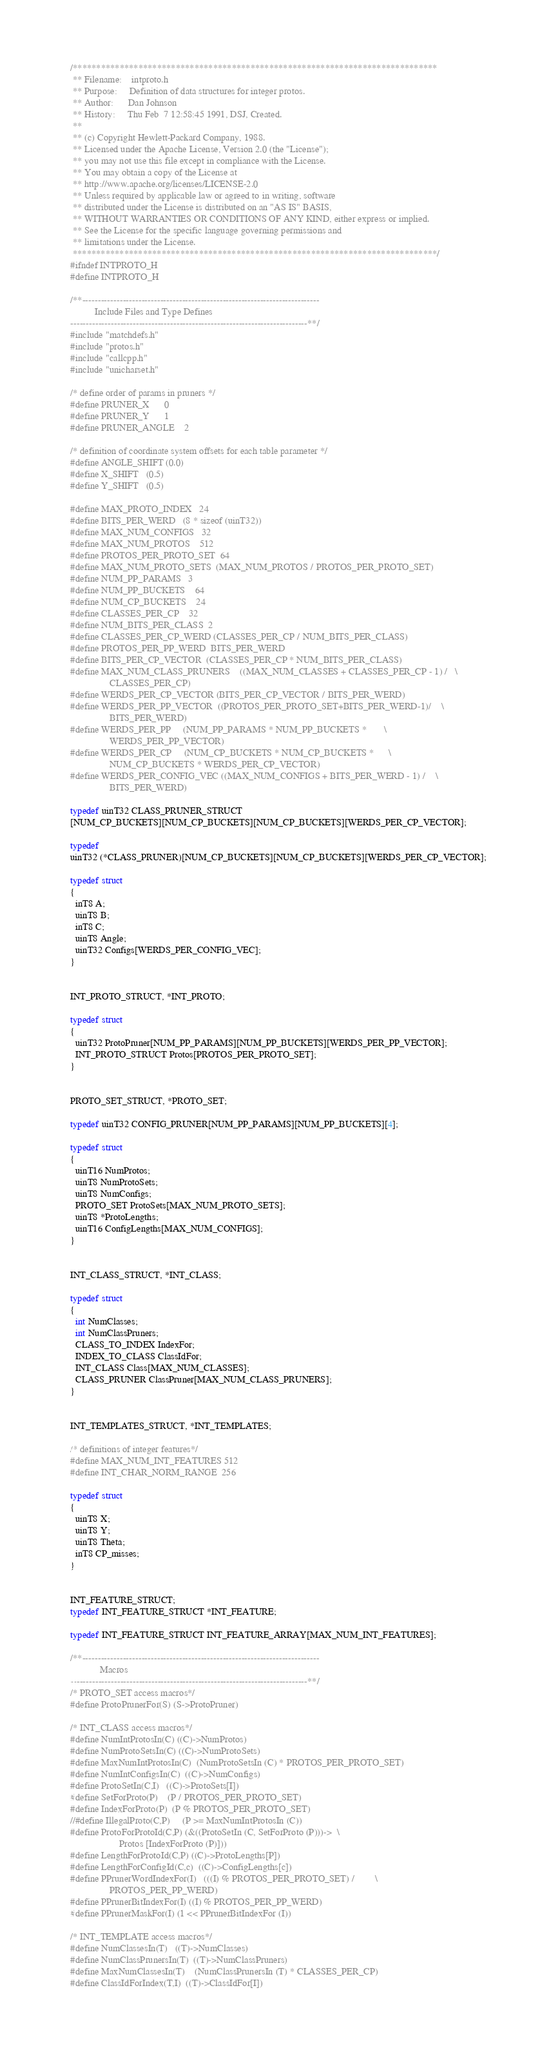Convert code to text. <code><loc_0><loc_0><loc_500><loc_500><_C_>/******************************************************************************
 **	Filename:    intproto.h
 **	Purpose:     Definition of data structures for integer protos.
 **	Author:      Dan Johnson
 **	History:     Thu Feb  7 12:58:45 1991, DSJ, Created.
 **
 **	(c) Copyright Hewlett-Packard Company, 1988.
 ** Licensed under the Apache License, Version 2.0 (the "License");
 ** you may not use this file except in compliance with the License.
 ** You may obtain a copy of the License at
 ** http://www.apache.org/licenses/LICENSE-2.0
 ** Unless required by applicable law or agreed to in writing, software
 ** distributed under the License is distributed on an "AS IS" BASIS,
 ** WITHOUT WARRANTIES OR CONDITIONS OF ANY KIND, either express or implied.
 ** See the License for the specific language governing permissions and
 ** limitations under the License.
 ******************************************************************************/
#ifndef INTPROTO_H
#define INTPROTO_H

/**----------------------------------------------------------------------------
          Include Files and Type Defines
----------------------------------------------------------------------------**/
#include "matchdefs.h"
#include "protos.h"
#include "callcpp.h"
#include "unicharset.h"

/* define order of params in pruners */
#define PRUNER_X      0
#define PRUNER_Y      1
#define PRUNER_ANGLE    2

/* definition of coordinate system offsets for each table parameter */
#define ANGLE_SHIFT (0.0)
#define X_SHIFT   (0.5)
#define Y_SHIFT   (0.5)

#define MAX_PROTO_INDEX   24
#define BITS_PER_WERD   (8 * sizeof (uinT32))
#define MAX_NUM_CONFIGS   32
#define MAX_NUM_PROTOS    512
#define PROTOS_PER_PROTO_SET  64
#define MAX_NUM_PROTO_SETS  (MAX_NUM_PROTOS / PROTOS_PER_PROTO_SET)
#define NUM_PP_PARAMS   3
#define NUM_PP_BUCKETS    64
#define NUM_CP_BUCKETS    24
#define CLASSES_PER_CP    32
#define NUM_BITS_PER_CLASS  2
#define CLASSES_PER_CP_WERD (CLASSES_PER_CP / NUM_BITS_PER_CLASS)
#define PROTOS_PER_PP_WERD  BITS_PER_WERD
#define BITS_PER_CP_VECTOR  (CLASSES_PER_CP * NUM_BITS_PER_CLASS)
#define MAX_NUM_CLASS_PRUNERS	((MAX_NUM_CLASSES + CLASSES_PER_CP - 1) /   \
				CLASSES_PER_CP)
#define WERDS_PER_CP_VECTOR (BITS_PER_CP_VECTOR / BITS_PER_WERD)
#define WERDS_PER_PP_VECTOR	((PROTOS_PER_PROTO_SET+BITS_PER_WERD-1)/    \
				BITS_PER_WERD)
#define WERDS_PER_PP		(NUM_PP_PARAMS * NUM_PP_BUCKETS *		\
				WERDS_PER_PP_VECTOR)
#define WERDS_PER_CP		(NUM_CP_BUCKETS * NUM_CP_BUCKETS *		\
				NUM_CP_BUCKETS * WERDS_PER_CP_VECTOR)
#define WERDS_PER_CONFIG_VEC	((MAX_NUM_CONFIGS + BITS_PER_WERD - 1) /    \
				BITS_PER_WERD)

typedef uinT32 CLASS_PRUNER_STRUCT
[NUM_CP_BUCKETS][NUM_CP_BUCKETS][NUM_CP_BUCKETS][WERDS_PER_CP_VECTOR];

typedef
uinT32 (*CLASS_PRUNER)[NUM_CP_BUCKETS][NUM_CP_BUCKETS][WERDS_PER_CP_VECTOR];

typedef struct
{
  inT8 A;
  uinT8 B;
  inT8 C;
  uinT8 Angle;
  uinT32 Configs[WERDS_PER_CONFIG_VEC];
}


INT_PROTO_STRUCT, *INT_PROTO;

typedef struct
{
  uinT32 ProtoPruner[NUM_PP_PARAMS][NUM_PP_BUCKETS][WERDS_PER_PP_VECTOR];
  INT_PROTO_STRUCT Protos[PROTOS_PER_PROTO_SET];
}


PROTO_SET_STRUCT, *PROTO_SET;

typedef uinT32 CONFIG_PRUNER[NUM_PP_PARAMS][NUM_PP_BUCKETS][4];

typedef struct
{
  uinT16 NumProtos;
  uinT8 NumProtoSets;
  uinT8 NumConfigs;
  PROTO_SET ProtoSets[MAX_NUM_PROTO_SETS];
  uinT8 *ProtoLengths;
  uinT16 ConfigLengths[MAX_NUM_CONFIGS];
}


INT_CLASS_STRUCT, *INT_CLASS;

typedef struct
{
  int NumClasses;
  int NumClassPruners;
  CLASS_TO_INDEX IndexFor;
  INDEX_TO_CLASS ClassIdFor;
  INT_CLASS Class[MAX_NUM_CLASSES];
  CLASS_PRUNER ClassPruner[MAX_NUM_CLASS_PRUNERS];
}


INT_TEMPLATES_STRUCT, *INT_TEMPLATES;

/* definitions of integer features*/
#define MAX_NUM_INT_FEATURES 512
#define INT_CHAR_NORM_RANGE  256

typedef struct
{
  uinT8 X;
  uinT8 Y;
  uinT8 Theta;
  inT8 CP_misses;
}


INT_FEATURE_STRUCT;
typedef INT_FEATURE_STRUCT *INT_FEATURE;

typedef INT_FEATURE_STRUCT INT_FEATURE_ARRAY[MAX_NUM_INT_FEATURES];

/**----------------------------------------------------------------------------
            Macros
----------------------------------------------------------------------------**/
/* PROTO_SET access macros*/
#define ProtoPrunerFor(S) (S->ProtoPruner)

/* INT_CLASS access macros*/
#define NumIntProtosIn(C) ((C)->NumProtos)
#define NumProtoSetsIn(C) ((C)->NumProtoSets)
#define MaxNumIntProtosIn(C)  (NumProtoSetsIn (C) * PROTOS_PER_PROTO_SET)
#define NumIntConfigsIn(C)  ((C)->NumConfigs)
#define ProtoSetIn(C,I)   ((C)->ProtoSets[I])
#define SetForProto(P)    (P / PROTOS_PER_PROTO_SET)
#define IndexForProto(P)  (P % PROTOS_PER_PROTO_SET)
//#define IllegalProto(C,P)     (P >= MaxNumIntProtosIn (C))
#define ProtoForProtoId(C,P)	(&((ProtoSetIn (C, SetForProto (P)))->	\
					Protos [IndexForProto (P)]))
#define LengthForProtoId(C,P) ((C)->ProtoLengths[P])
#define LengthForConfigId(C,c)  ((C)->ConfigLengths[c])
#define PPrunerWordIndexFor(I)	(((I) % PROTOS_PER_PROTO_SET) /		\
				PROTOS_PER_PP_WERD)
#define PPrunerBitIndexFor(I) ((I) % PROTOS_PER_PP_WERD)
#define PPrunerMaskFor(I) (1 << PPrunerBitIndexFor (I))

/* INT_TEMPLATE access macros*/
#define NumClassesIn(T)   ((T)->NumClasses)
#define NumClassPrunersIn(T)  ((T)->NumClassPruners)
#define MaxNumClassesIn(T)    (NumClassPrunersIn (T) * CLASSES_PER_CP)
#define ClassIdForIndex(T,I)  ((T)->ClassIdFor[I])</code> 